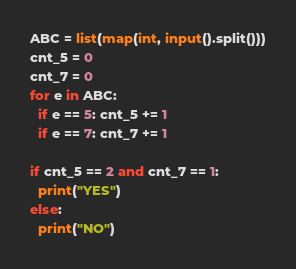<code> <loc_0><loc_0><loc_500><loc_500><_Python_>ABC = list(map(int, input().split()))
cnt_5 = 0
cnt_7 = 0
for e in ABC:
  if e == 5: cnt_5 += 1
  if e == 7: cnt_7 += 1
 
if cnt_5 == 2 and cnt_7 == 1:
  print("YES")
else:
  print("NO")

</code> 